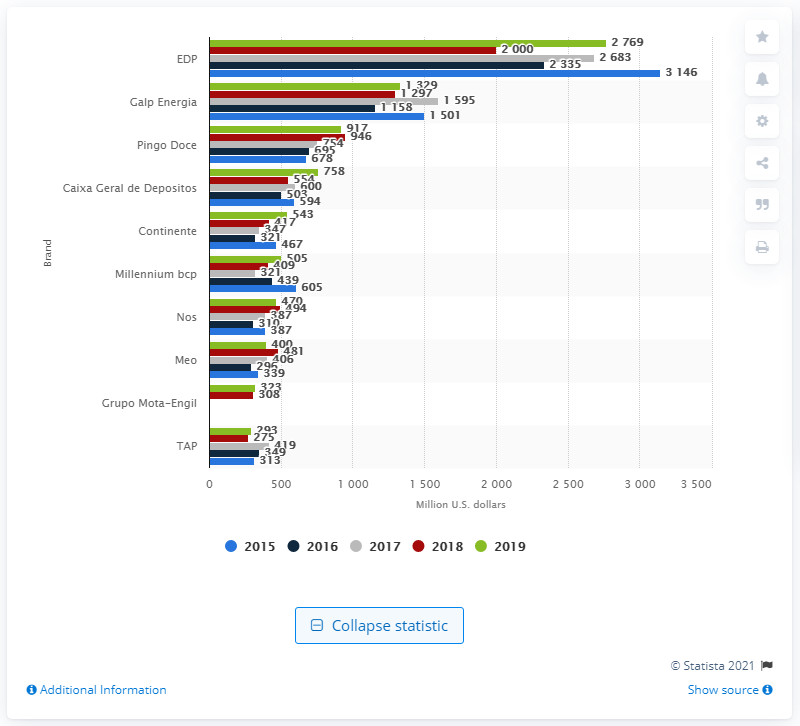Indicate a few pertinent items in this graphic. In 2019, the brand value of EDP was estimated to be approximately 2,683. 